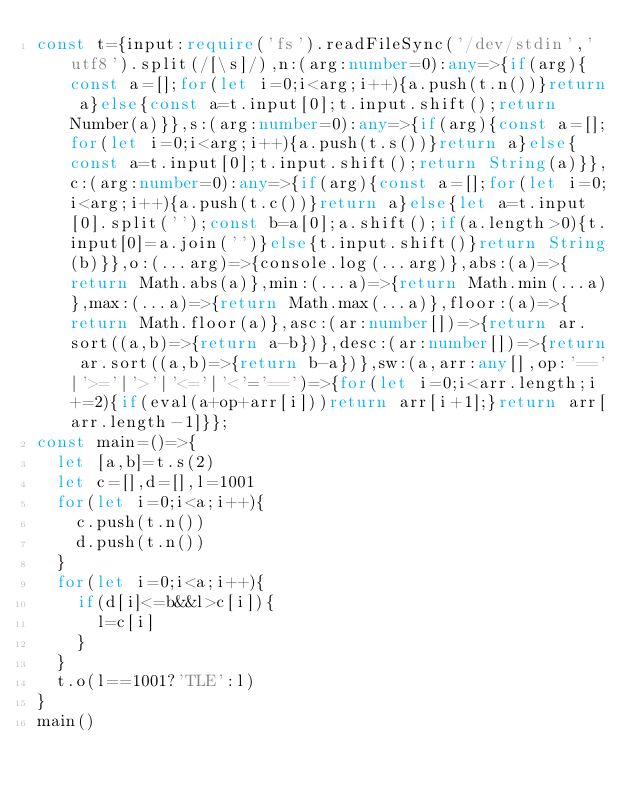<code> <loc_0><loc_0><loc_500><loc_500><_TypeScript_>const t={input:require('fs').readFileSync('/dev/stdin','utf8').split(/[\s]/),n:(arg:number=0):any=>{if(arg){const a=[];for(let i=0;i<arg;i++){a.push(t.n())}return a}else{const a=t.input[0];t.input.shift();return Number(a)}},s:(arg:number=0):any=>{if(arg){const a=[];for(let i=0;i<arg;i++){a.push(t.s())}return a}else{const a=t.input[0];t.input.shift();return String(a)}},c:(arg:number=0):any=>{if(arg){const a=[];for(let i=0;i<arg;i++){a.push(t.c())}return a}else{let a=t.input[0].split('');const b=a[0];a.shift();if(a.length>0){t.input[0]=a.join('')}else{t.input.shift()}return String(b)}},o:(...arg)=>{console.log(...arg)},abs:(a)=>{return Math.abs(a)},min:(...a)=>{return Math.min(...a)},max:(...a)=>{return Math.max(...a)},floor:(a)=>{return Math.floor(a)},asc:(ar:number[])=>{return ar.sort((a,b)=>{return a-b})},desc:(ar:number[])=>{return ar.sort((a,b)=>{return b-a})},sw:(a,arr:any[],op:'=='|'>='|'>'|'<='|'<'='==')=>{for(let i=0;i<arr.length;i+=2){if(eval(a+op+arr[i]))return arr[i+1];}return arr[arr.length-1]}};
const main=()=>{
  let [a,b]=t.s(2)
  let c=[],d=[],l=1001
  for(let i=0;i<a;i++){
    c.push(t.n())
    d.push(t.n())
  }
  for(let i=0;i<a;i++){
    if(d[i]<=b&&l>c[i]){
      l=c[i]
    }
  }
  t.o(l==1001?'TLE':l)
}
main()</code> 